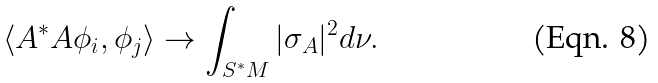<formula> <loc_0><loc_0><loc_500><loc_500>\langle A ^ { * } A \phi _ { i } , \phi _ { j } \rangle \to \int _ { S ^ { * } M } | \sigma _ { A } | ^ { 2 } d \nu .</formula> 